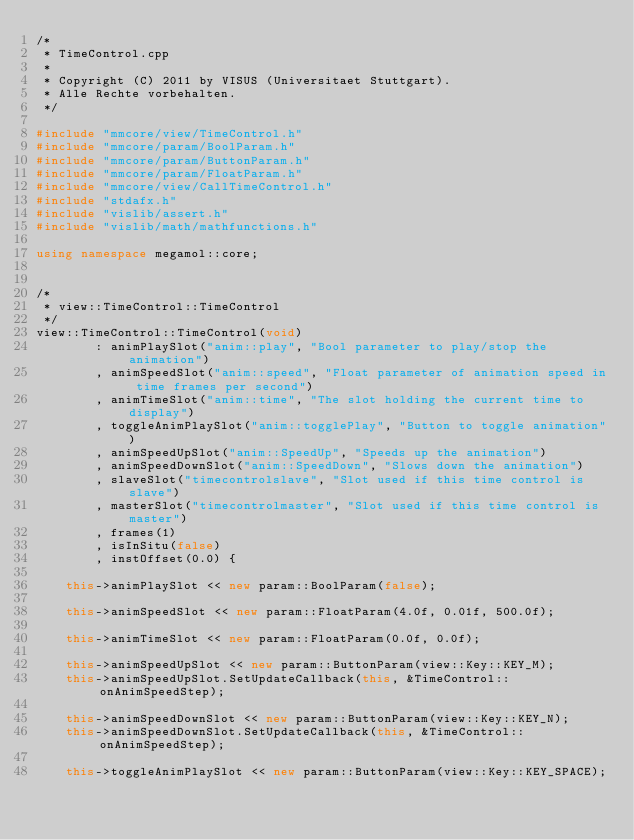Convert code to text. <code><loc_0><loc_0><loc_500><loc_500><_C++_>/*
 * TimeControl.cpp
 *
 * Copyright (C) 2011 by VISUS (Universitaet Stuttgart).
 * Alle Rechte vorbehalten.
 */

#include "mmcore/view/TimeControl.h"
#include "mmcore/param/BoolParam.h"
#include "mmcore/param/ButtonParam.h"
#include "mmcore/param/FloatParam.h"
#include "mmcore/view/CallTimeControl.h"
#include "stdafx.h"
#include "vislib/assert.h"
#include "vislib/math/mathfunctions.h"

using namespace megamol::core;


/*
 * view::TimeControl::TimeControl
 */
view::TimeControl::TimeControl(void)
        : animPlaySlot("anim::play", "Bool parameter to play/stop the animation")
        , animSpeedSlot("anim::speed", "Float parameter of animation speed in time frames per second")
        , animTimeSlot("anim::time", "The slot holding the current time to display")
        , toggleAnimPlaySlot("anim::togglePlay", "Button to toggle animation")
        , animSpeedUpSlot("anim::SpeedUp", "Speeds up the animation")
        , animSpeedDownSlot("anim::SpeedDown", "Slows down the animation")
        , slaveSlot("timecontrolslave", "Slot used if this time control is slave")
        , masterSlot("timecontrolmaster", "Slot used if this time control is master")
        , frames(1)
        , isInSitu(false)
        , instOffset(0.0) {

    this->animPlaySlot << new param::BoolParam(false);

    this->animSpeedSlot << new param::FloatParam(4.0f, 0.01f, 500.0f);

    this->animTimeSlot << new param::FloatParam(0.0f, 0.0f);

    this->animSpeedUpSlot << new param::ButtonParam(view::Key::KEY_M);
    this->animSpeedUpSlot.SetUpdateCallback(this, &TimeControl::onAnimSpeedStep);

    this->animSpeedDownSlot << new param::ButtonParam(view::Key::KEY_N);
    this->animSpeedDownSlot.SetUpdateCallback(this, &TimeControl::onAnimSpeedStep);

    this->toggleAnimPlaySlot << new param::ButtonParam(view::Key::KEY_SPACE);</code> 